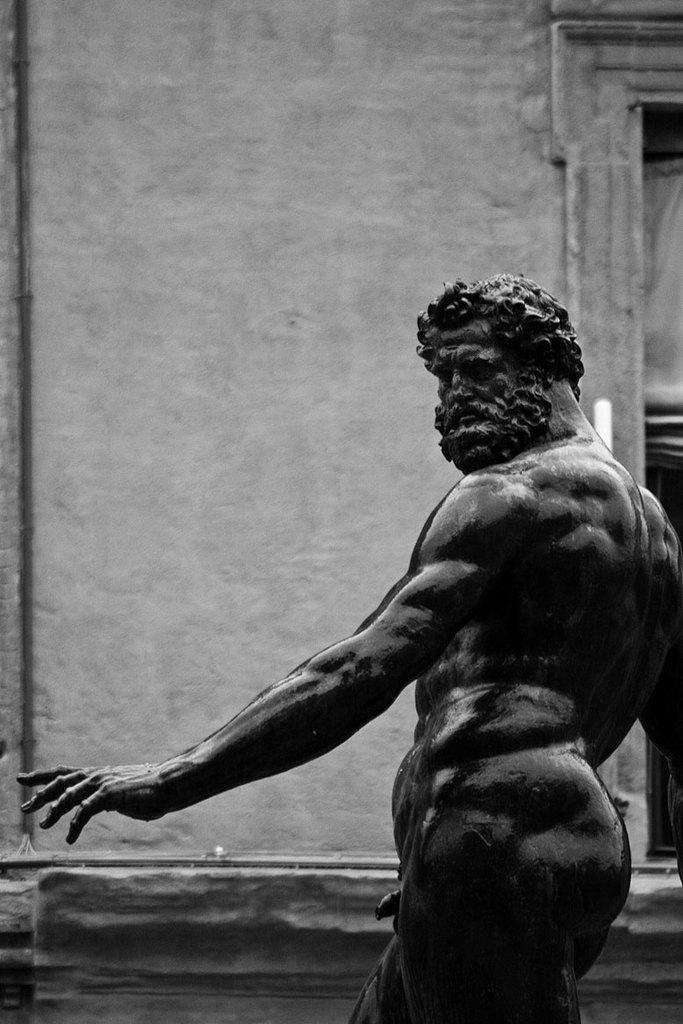What is the color scheme of the image? The image is black and white. What can be seen on the left side of the image? There is a man statue on the left side of the image. What is located behind the statue? There is a wall behind the statue. What type of fish can be seen swimming near the statue in the image? There are no fish present in the image; it is a black and white image featuring a man statue and a wall. 